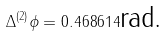<formula> <loc_0><loc_0><loc_500><loc_500>\Delta ^ { \left ( 2 \right ) } \phi = 0 . 4 6 8 6 1 4 \text {rad.}</formula> 